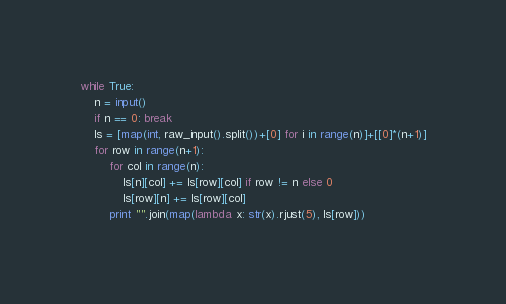<code> <loc_0><loc_0><loc_500><loc_500><_Python_>while True:
	n = input()
	if n == 0: break
	ls = [map(int, raw_input().split())+[0] for i in range(n)]+[[0]*(n+1)]
	for row in range(n+1):
		for col in range(n):
			ls[n][col] += ls[row][col] if row != n else 0
			ls[row][n] += ls[row][col]
		print "".join(map(lambda x: str(x).rjust(5), ls[row]))</code> 